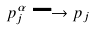<formula> <loc_0><loc_0><loc_500><loc_500>p _ { j } ^ { \alpha } \longrightarrow p _ { j }</formula> 